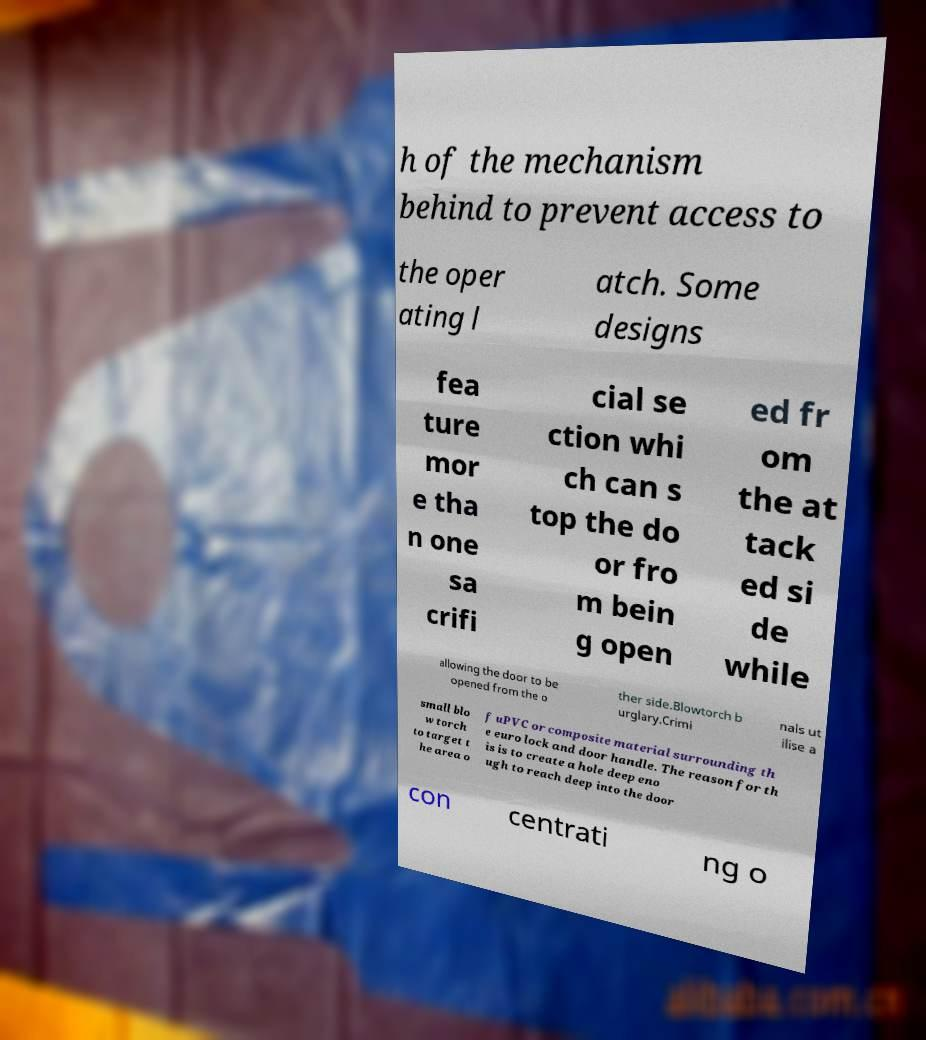Could you extract and type out the text from this image? h of the mechanism behind to prevent access to the oper ating l atch. Some designs fea ture mor e tha n one sa crifi cial se ction whi ch can s top the do or fro m bein g open ed fr om the at tack ed si de while allowing the door to be opened from the o ther side.Blowtorch b urglary.Crimi nals ut ilise a small blo w torch to target t he area o f uPVC or composite material surrounding th e euro lock and door handle. The reason for th is is to create a hole deep eno ugh to reach deep into the door con centrati ng o 